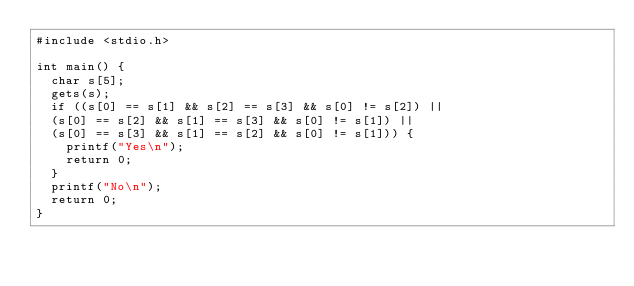<code> <loc_0><loc_0><loc_500><loc_500><_C_>#include <stdio.h>

int main() {
  char s[5];
  gets(s);
  if ((s[0] == s[1] && s[2] == s[3] && s[0] != s[2]) ||
  (s[0] == s[2] && s[1] == s[3] && s[0] != s[1]) ||
  (s[0] == s[3] && s[1] == s[2] && s[0] != s[1])) {
    printf("Yes\n");
    return 0;
  }
  printf("No\n");
  return 0;
}
</code> 